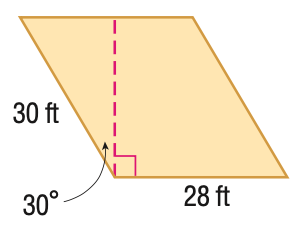Answer the mathemtical geometry problem and directly provide the correct option letter.
Question: Find the area of the parallelogram. Round to the nearest tenth if necessary.
Choices: A: 420 B: 594.0 C: 727.5 D: 840 C 